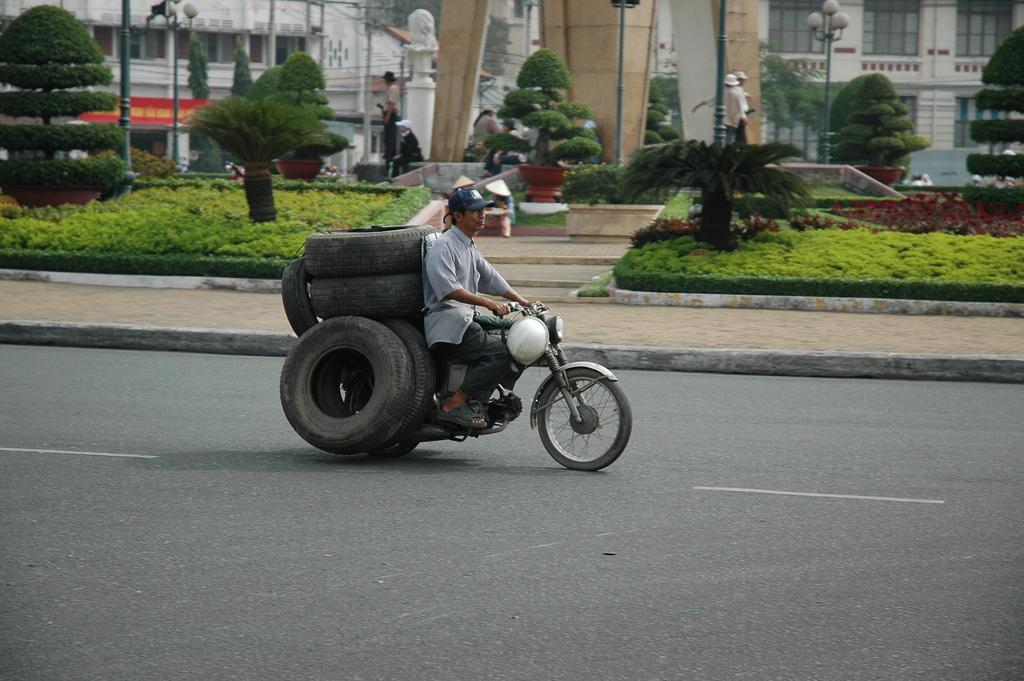Describe this image in one or two sentences. In this image on the top there are two buildings and grass and plants and flower pots are there and on the road there is one motor cycle and on that motor cycle there is one person who is sitting and riding and he is carrying a tires and in the right side and left side there are poles. 